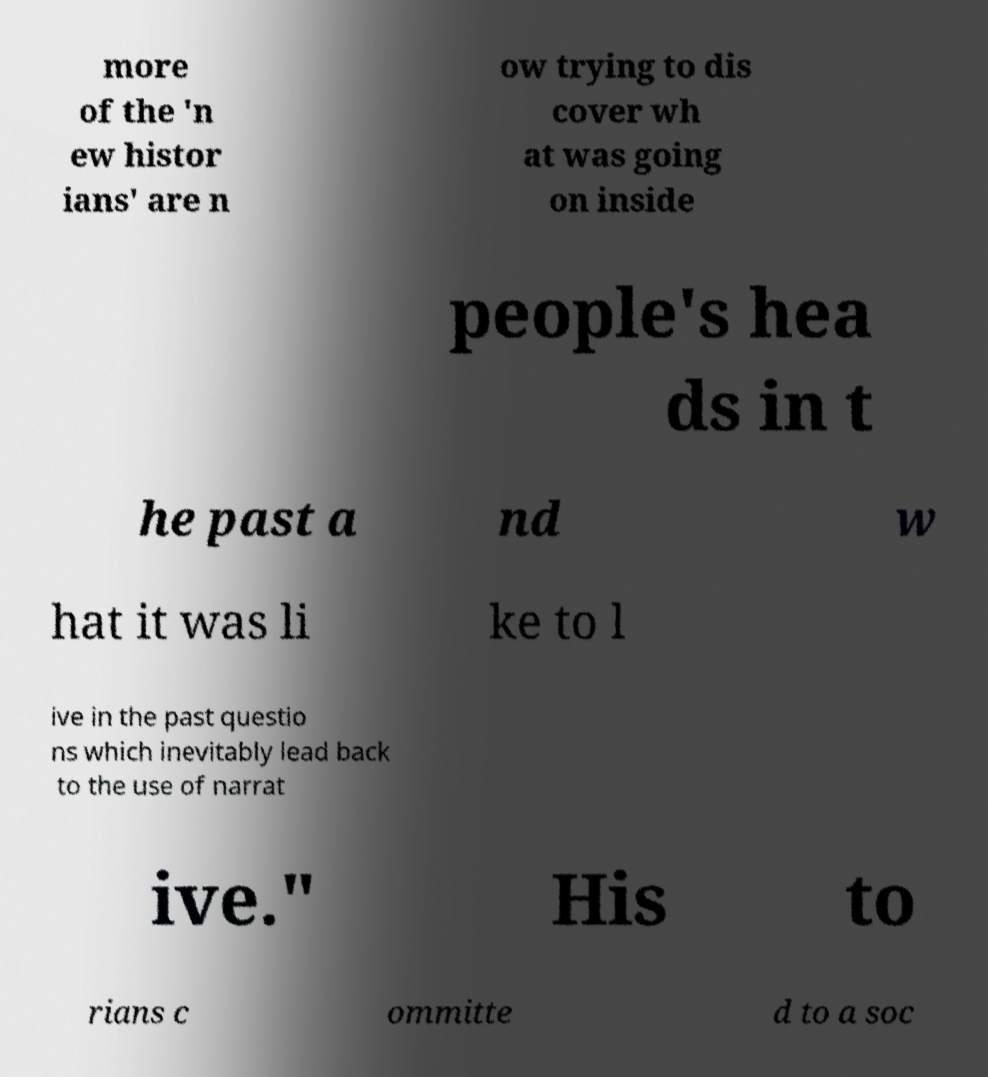What messages or text are displayed in this image? I need them in a readable, typed format. more of the 'n ew histor ians' are n ow trying to dis cover wh at was going on inside people's hea ds in t he past a nd w hat it was li ke to l ive in the past questio ns which inevitably lead back to the use of narrat ive." His to rians c ommitte d to a soc 